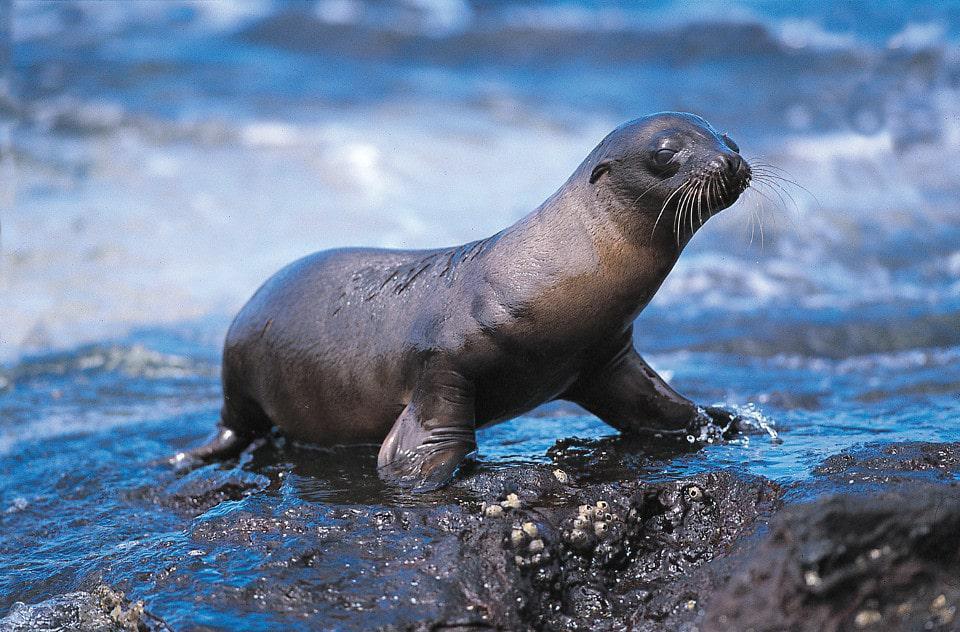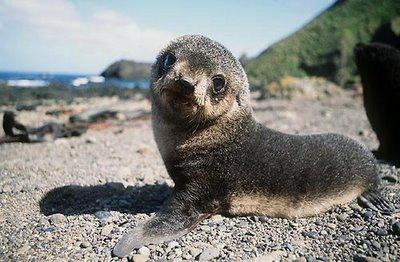The first image is the image on the left, the second image is the image on the right. For the images displayed, is the sentence "One image features a baby sea lion next to an adult sea lion" factually correct? Answer yes or no. No. The first image is the image on the left, the second image is the image on the right. Considering the images on both sides, is "There are exactly two sea lions in total." valid? Answer yes or no. Yes. 